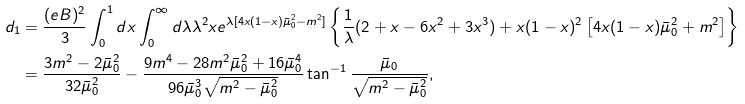<formula> <loc_0><loc_0><loc_500><loc_500>d _ { 1 } & = \frac { ( e B ) ^ { 2 } } { 3 } \int _ { 0 } ^ { 1 } d x \int _ { 0 } ^ { \infty } d \lambda \lambda ^ { 2 } x e ^ { \lambda [ 4 x ( 1 - x ) \bar { \mu } _ { 0 } ^ { 2 } - m ^ { 2 } ] } \left \{ \frac { 1 } { \lambda } ( 2 + x - 6 x ^ { 2 } + 3 x ^ { 3 } ) + x ( 1 - x ) ^ { 2 } \left [ 4 x ( 1 - x ) \bar { \mu } _ { 0 } ^ { 2 } + m ^ { 2 } \right ] \right \} \\ & = \frac { 3 m ^ { 2 } - 2 \bar { \mu } _ { 0 } ^ { 2 } } { 3 2 \bar { \mu } _ { 0 } ^ { 2 } } - \frac { 9 m ^ { 4 } - 2 8 m ^ { 2 } \bar { \mu } _ { 0 } ^ { 2 } + 1 6 \bar { \mu } _ { 0 } ^ { 4 } } { 9 6 \bar { \mu } _ { 0 } ^ { 3 } \sqrt { m ^ { 2 } - \bar { \mu } _ { 0 } ^ { 2 } } } \tan ^ { - 1 } \frac { \bar { \mu } _ { 0 } } { \sqrt { m ^ { 2 } - \bar { \mu } _ { 0 } ^ { 2 } } } ,</formula> 